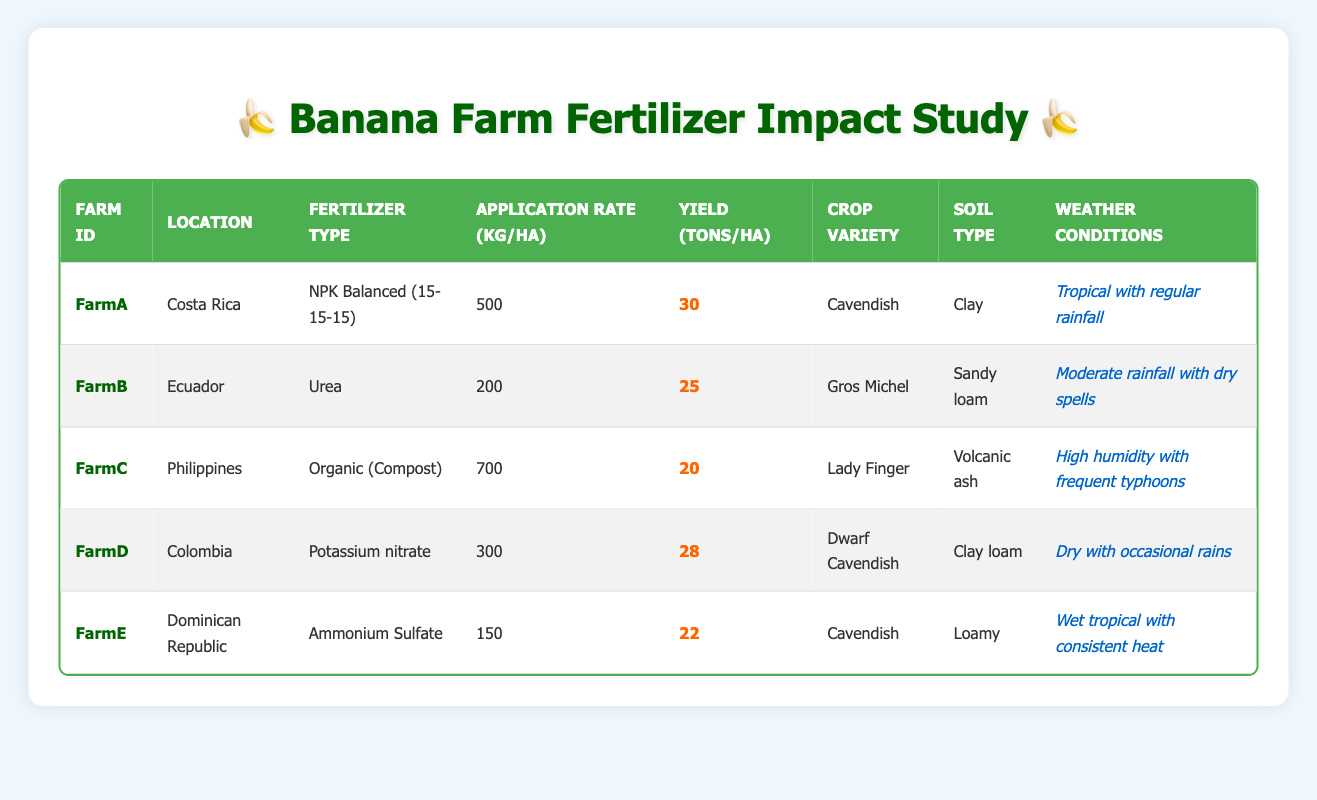What is the highest yield recorded in the table? The highest yield is found in FarmA, with a yield of 30 tons per hectare. Checking each farm's yield, FarmA has the highest value, indicating that NPK Balanced fertilizer might have contributed positively to the yield.
Answer: 30 tons per hectare Which fertilizer type is used on FarmB? FarmB uses Urea as its fertilizer type. This information can be found in the Fertilizer Type column corresponding to FarmB's row.
Answer: Urea What is the average application rate of fertilizer for all farms? To find the average application rate, first add the application rates from all farms: 500 + 200 + 700 + 300 + 150 = 1850 kg/ha. Then, divide by the number of farms (5): 1850 / 5 = 370 kg/ha.
Answer: 370 kg/ha Is the yield of FarmE higher than that of FarmC? FarmE has a yield of 22 tons per hectare, while FarmC has a yield of 20 tons per hectare. Since 22 > 20, this statement is true.
Answer: Yes Which farm achieved a yield of 25 tons per hectare? FarmB achieved a yield of 25 tons per hectare, as indicated in the Yield column for that farm.
Answer: FarmB What is the difference in yield between the highest and the lowest yield recorded? The highest yield (30 tons per hectare from FarmA) and the lowest yield (20 tons per hectare from FarmC) are considered. The difference is calculated as 30 - 20 = 10 tons per hectare.
Answer: 10 tons per hectare Does FarmD use Organic fertilizer? FarmD uses Potassium nitrate as indicated in the Fertilizer Type column. Since this is not an organic fertilizer, the answer is false.
Answer: No Which crop variety corresponds with the highest application rate of fertilizer? FarmC uses an organic fertilizer with the highest application rate of 700 kg per hectare. The crop variety for FarmC is Lady Finger, establishing a link between the higher application and this specific crop.
Answer: Lady Finger What is the yield of FarmA compared to FarmD? FarmA has a yield of 30 tons per hectare, and FarmD has a yield of 28 tons per hectare. Comparing these shows that FarmA has a higher yield than FarmD.
Answer: FarmA has a higher yield 